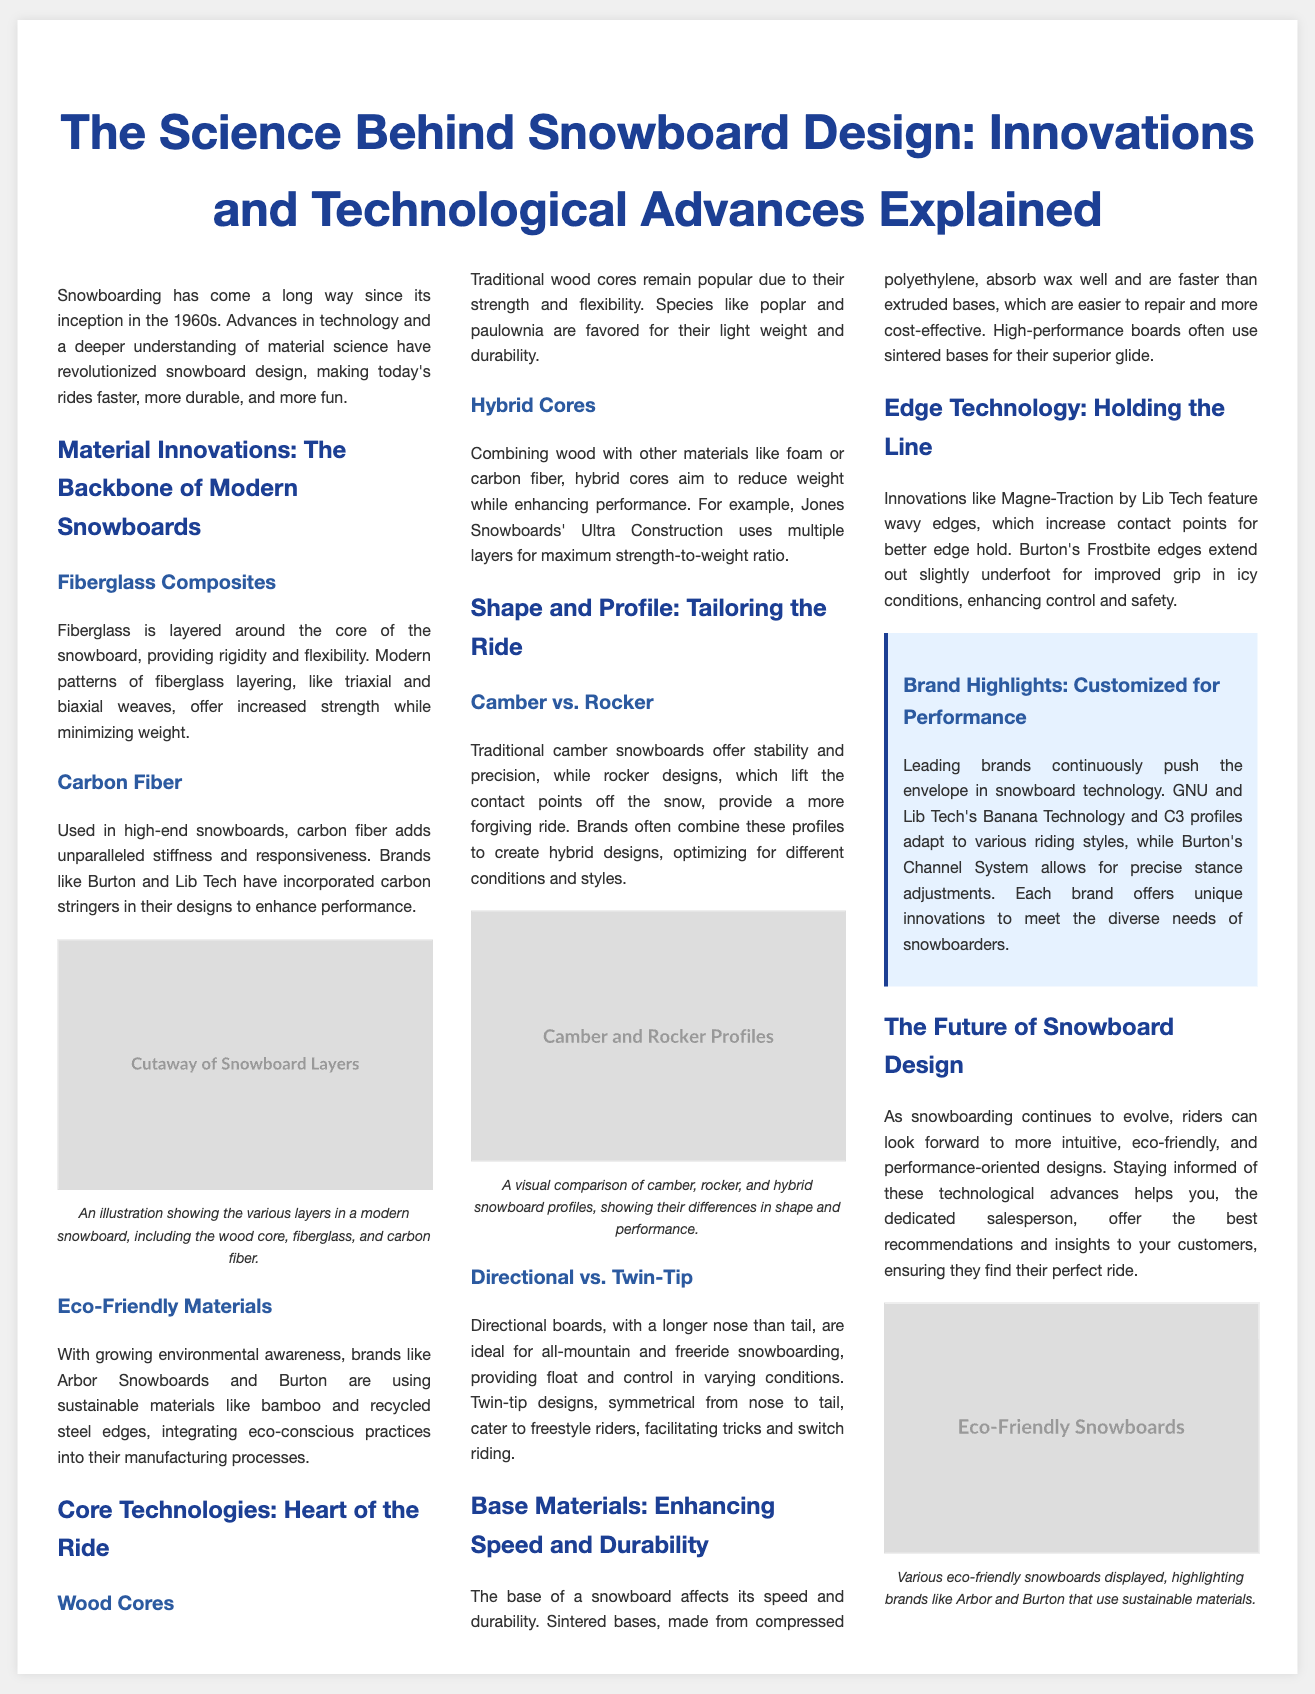What is the title of the article? The title of the article is prominently displayed at the top of the document, introducing the topic of snowboard design.
Answer: The Science Behind Snowboard Design: Innovations and Technological Advances Explained Which material is commonly used for the core of traditional snowboards? The section discussing wood cores mentions that traditional wood cores are popular due to their strength and flexibility.
Answer: Wood What type of fiberglass layering provides increased strength while minimizing weight? The article describes modern patterns of fiberglass layering, specifically focusing on triaxial and biaxial weaves for enhanced performance.
Answer: Biaxial weaves Which brand utilizes eco-friendly materials like bamboo in their snowboards? The section on eco-friendly materials lists Arbor Snowboards as a brand that incorporates sustainable materials in their manufacturing processes.
Answer: Arbor Snowboards What technology features wavy edges for better edge hold? Edge technology is discussed in the document, mentioning Lib Tech's Magne-Traction specifically for its unique wavy edges.
Answer: Magne-Traction Which snowboard profile is described as more forgiving? The comparison between camber and rocker profiles explains that rocker designs provide a more forgiving ride compared to traditional camber.
Answer: Rocker What are the benefits of sintered bases over extruded bases? The section about base materials outlines that sintered bases absorb wax well and offer faster speeds, distinguishing them from extruded bases.
Answer: Faster speeds What innovative system does Burton use for precise stance adjustments? The document highlights Burton’s Channel System as a technological feature that allows for precise stance adjustments on their snowboards.
Answer: Channel System Which manufacturers are mentioned for their unique snowboard technologies? Brand highlights points out GNU, Lib Tech, and Burton as examples of manufacturers pushing the envelope with their snowboard innovations.
Answer: GNU and Lib Tech 